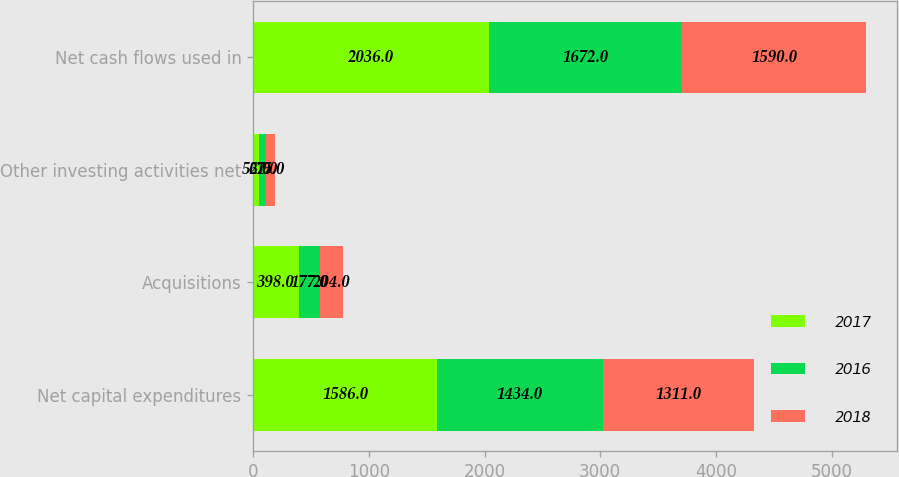Convert chart. <chart><loc_0><loc_0><loc_500><loc_500><stacked_bar_chart><ecel><fcel>Net capital expenditures<fcel>Acquisitions<fcel>Other investing activities net<fcel>Net cash flows used in<nl><fcel>2017<fcel>1586<fcel>398<fcel>52<fcel>2036<nl><fcel>2016<fcel>1434<fcel>177<fcel>61<fcel>1672<nl><fcel>2018<fcel>1311<fcel>204<fcel>75<fcel>1590<nl></chart> 